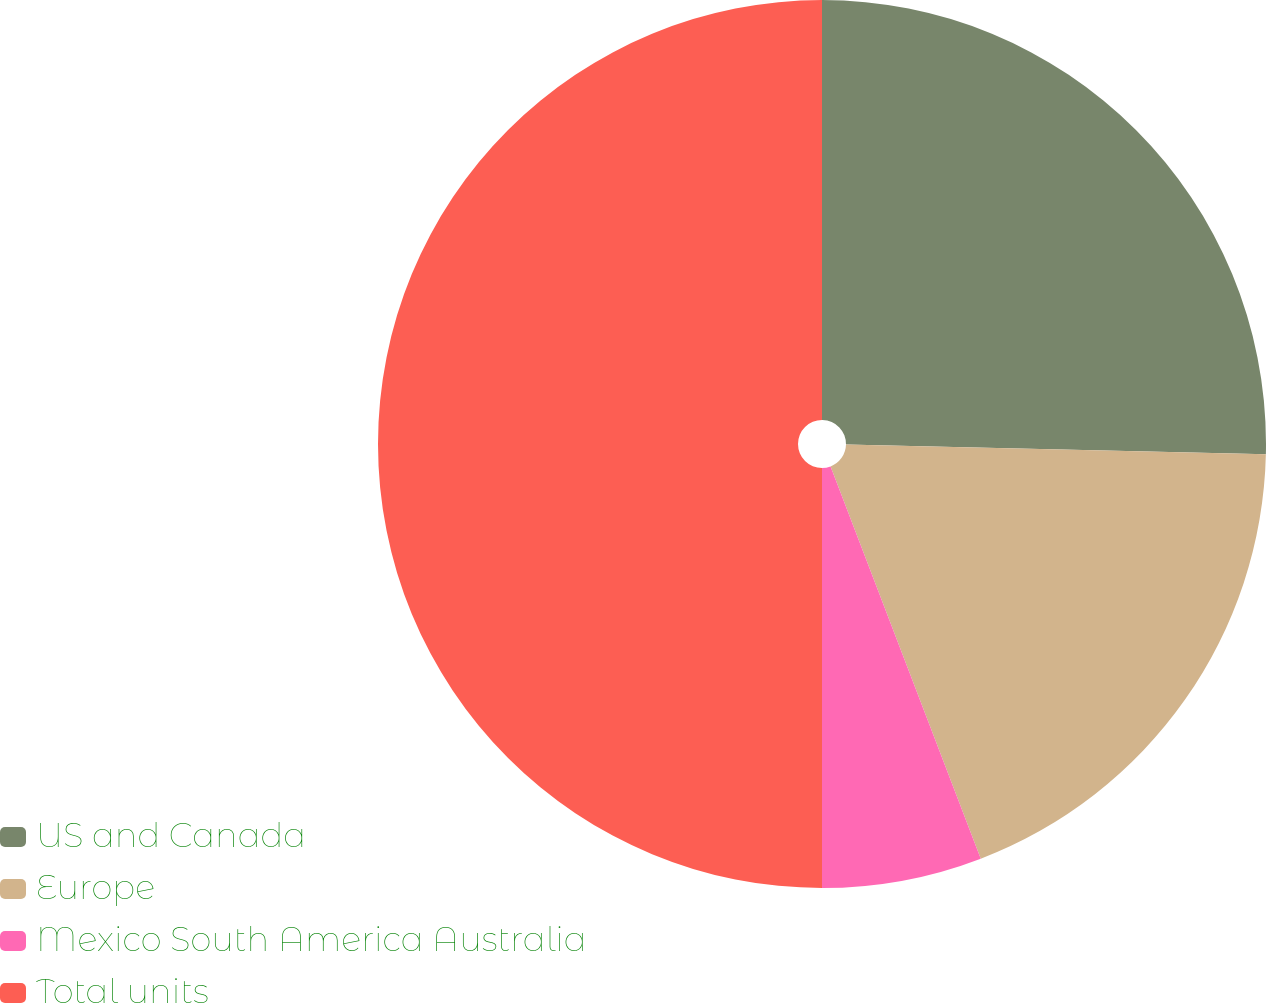Convert chart to OTSL. <chart><loc_0><loc_0><loc_500><loc_500><pie_chart><fcel>US and Canada<fcel>Europe<fcel>Mexico South America Australia<fcel>Total units<nl><fcel>25.37%<fcel>18.81%<fcel>5.82%<fcel>50.0%<nl></chart> 